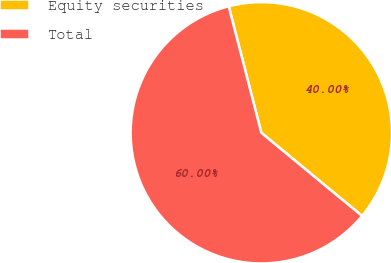<chart> <loc_0><loc_0><loc_500><loc_500><pie_chart><fcel>Equity securities<fcel>Total<nl><fcel>40.0%<fcel>60.0%<nl></chart> 